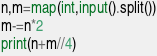Convert code to text. <code><loc_0><loc_0><loc_500><loc_500><_Python_>n,m=map(int,input().split())
m-=n*2
print(n+m//4)</code> 